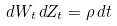Convert formula to latex. <formula><loc_0><loc_0><loc_500><loc_500>d W _ { t } \, d Z _ { t } = \rho \, d t</formula> 